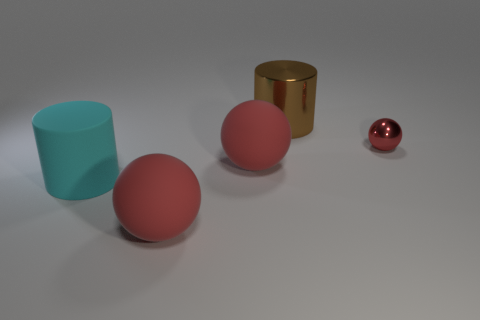How many red spheres must be subtracted to get 1 red spheres? 2 Subtract all tiny spheres. How many spheres are left? 2 Add 3 small gray matte things. How many objects exist? 8 Subtract all brown cylinders. How many cylinders are left? 1 Subtract all large brown metallic cylinders. Subtract all rubber balls. How many objects are left? 2 Add 2 big red rubber spheres. How many big red rubber spheres are left? 4 Add 5 big red objects. How many big red objects exist? 7 Subtract 1 red balls. How many objects are left? 4 Subtract all spheres. How many objects are left? 2 Subtract all brown cylinders. Subtract all purple cubes. How many cylinders are left? 1 